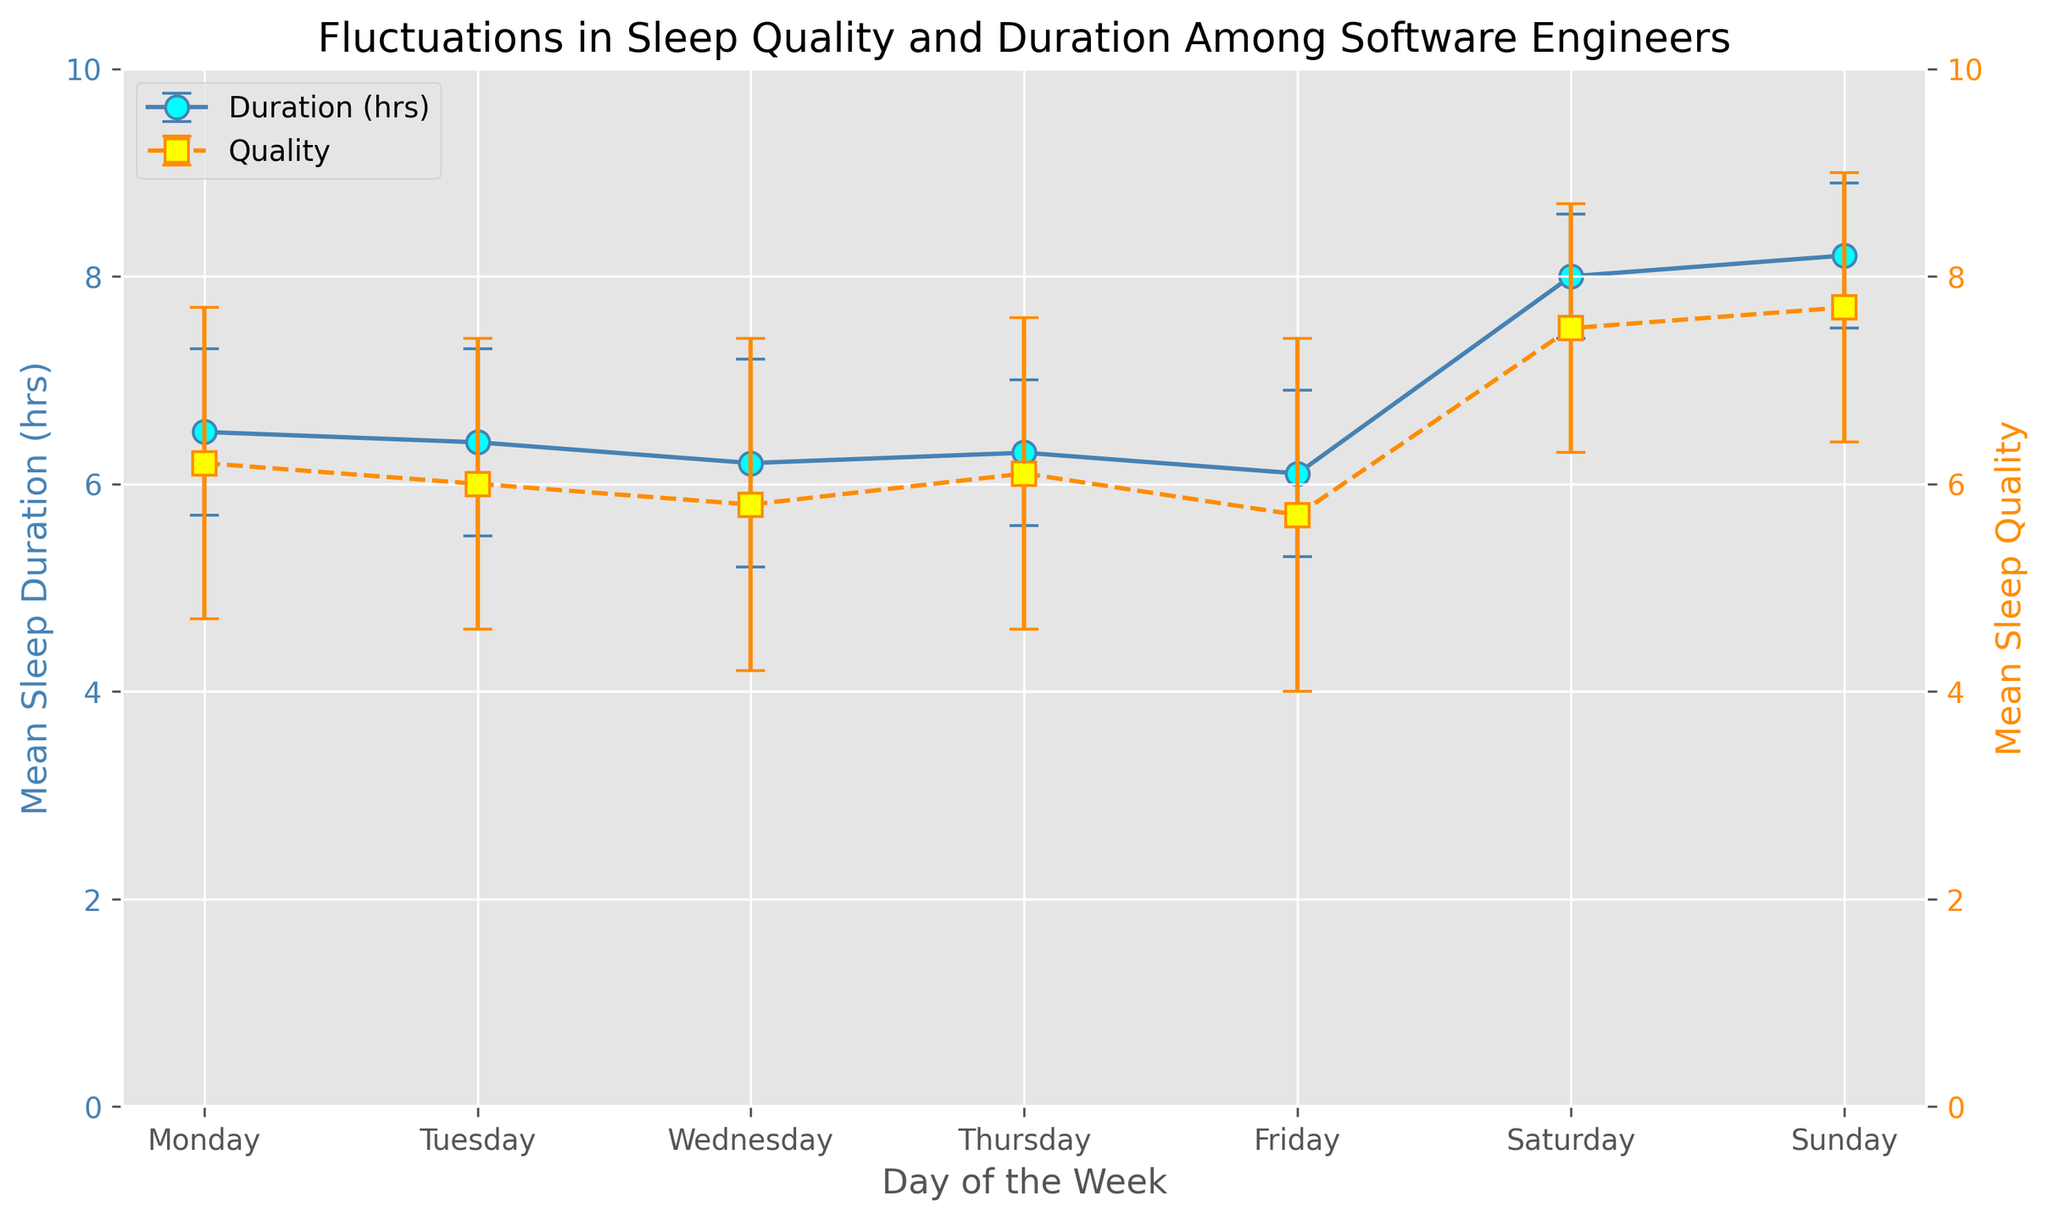Which days show the highest mean sleep quality? To identify the days with the highest mean sleep quality, look for the days with the highest points on the 'Sleep Quality' line (orange dashes). According to the graph, Saturday and Sunday have the highest mean sleep quality.
Answer: Saturday and Sunday What is the difference in mean sleep duration between Wednesday and Sunday? Find the mean sleep duration for Wednesday (6.2 hours) and Sunday (8.2 hours) and subtract the smaller value from the larger. 8.2 - 6.2 = 2 hours.
Answer: 2 hours Which day has the lowest mean sleep duration, and what is the value? Look for the day with the lowest point on the 'Sleep Duration' line (blue) and note down the corresponding value. According to the graph, Friday has the lowest mean sleep duration at 6.1 hours.
Answer: Friday, 6.1 hours On which days are the error bars for sleep quality the longest? The length of error bars represents the standard deviation. The longest error bars for sleep quality (orange line) are seen on Friday.
Answer: Friday What is the average mean sleep quality for workdays (Monday to Friday)? Sum the mean sleep quality values for each workday (6.2, 6.0, 5.8, 6.1, 5.7) and then divide by 5 to find the average. (6.2 + 6.0 + 5.8 + 6.1 + 5.7) / 5 = 5.96
Answer: 5.96 Compare the mean sleep duration between workdays and weekends. Which period has a higher average duration? For workdays (Monday to Friday), sum the mean durations (6.5, 6.4, 6.2, 6.3, 6.1) and divide by 5. For weekends (Saturday and Sunday), sum the mean durations (8.0, 8.2) and divide by 2. Then compare the two averages. Workdays: (6.5 + 6.4 + 6.2 + 6.3 + 6.1) / 5 = 6.3 hours. Weekends: (8.0 + 8.2) / 2 = 8.1 hours. Weekends have a higher average duration.
Answer: Weekends What is the sum of the mean sleep quality for Saturday and Sunday? Add mean sleep quality values for Saturday (7.5) and Sunday (7.7). 7.5 + 7.7 = 15.2
Answer: 15.2 How does the mean sleep quality on Monday compare to Tuesday's? Compare the mean sleep quality values for Monday (6.2) and Tuesday (6.0). Monday's mean sleep quality is higher.
Answer: Monday's quality is higher Which day has the smallest variation in sleep duration and how is this shown? The day with the smallest error bar (standard deviation) for sleep duration (blue line) indicates the smallest variation. Saturday shows the smallest error bar for sleep duration.
Answer: Saturday How much does the mean sleep duration increase from Friday to Saturday? Find the mean sleep duration on Friday (6.1) and on Saturday (8.0). Subtract Friday's value from Saturday's. 8.0 - 6.1 = 1.9 hours.
Answer: 1.9 hours What is the highest mean sleep duration recorded in the week, and on which day does it occur? Look for the highest point on the 'Sleep Duration' line (blue) and note the corresponding value and day. The highest mean sleep duration is 8.2 hours on Sunday.
Answer: 8.2 hours on Sunday 